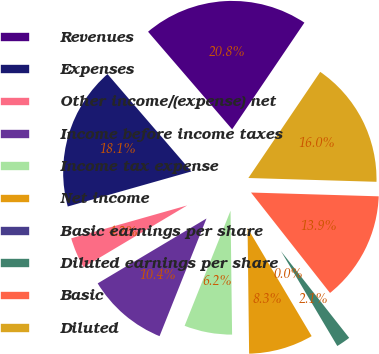Convert chart to OTSL. <chart><loc_0><loc_0><loc_500><loc_500><pie_chart><fcel>Revenues<fcel>Expenses<fcel>Other income/(expense) net<fcel>Income before income taxes<fcel>Income tax expense<fcel>Net income<fcel>Basic earnings per share<fcel>Diluted earnings per share<fcel>Basic<fcel>Diluted<nl><fcel>20.79%<fcel>18.08%<fcel>4.16%<fcel>10.4%<fcel>6.24%<fcel>8.32%<fcel>0.01%<fcel>2.08%<fcel>13.92%<fcel>16.0%<nl></chart> 